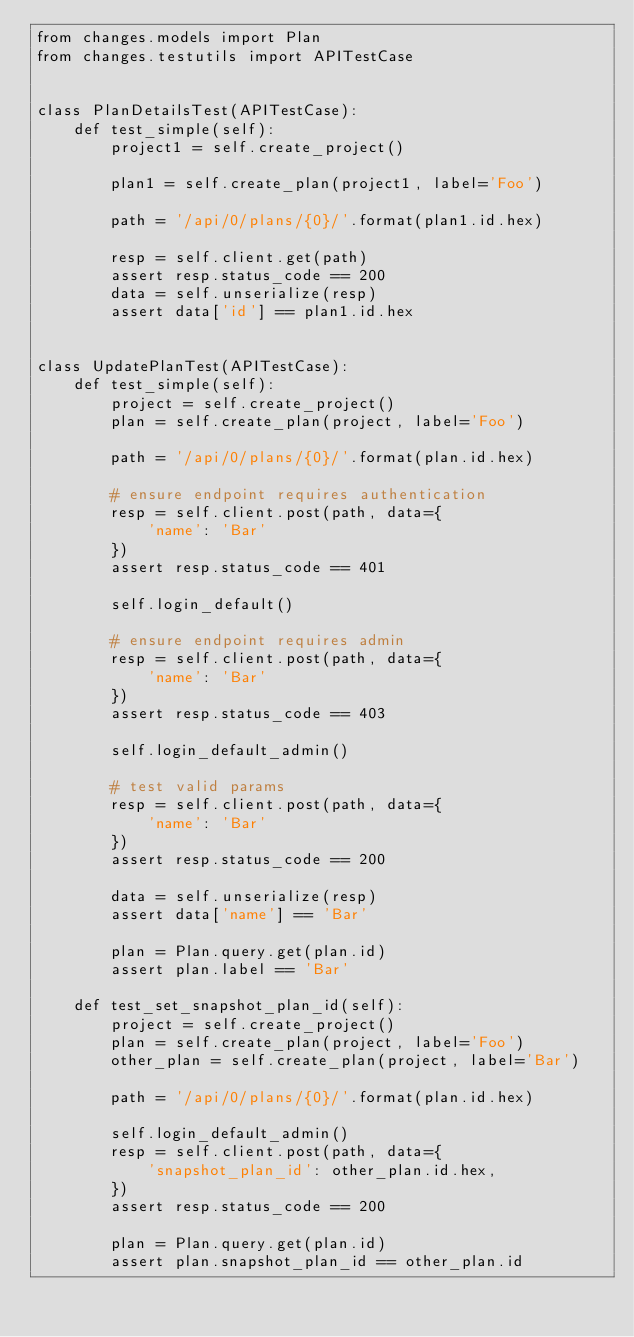<code> <loc_0><loc_0><loc_500><loc_500><_Python_>from changes.models import Plan
from changes.testutils import APITestCase


class PlanDetailsTest(APITestCase):
    def test_simple(self):
        project1 = self.create_project()

        plan1 = self.create_plan(project1, label='Foo')

        path = '/api/0/plans/{0}/'.format(plan1.id.hex)

        resp = self.client.get(path)
        assert resp.status_code == 200
        data = self.unserialize(resp)
        assert data['id'] == plan1.id.hex


class UpdatePlanTest(APITestCase):
    def test_simple(self):
        project = self.create_project()
        plan = self.create_plan(project, label='Foo')

        path = '/api/0/plans/{0}/'.format(plan.id.hex)

        # ensure endpoint requires authentication
        resp = self.client.post(path, data={
            'name': 'Bar'
        })
        assert resp.status_code == 401

        self.login_default()

        # ensure endpoint requires admin
        resp = self.client.post(path, data={
            'name': 'Bar'
        })
        assert resp.status_code == 403

        self.login_default_admin()

        # test valid params
        resp = self.client.post(path, data={
            'name': 'Bar'
        })
        assert resp.status_code == 200

        data = self.unserialize(resp)
        assert data['name'] == 'Bar'

        plan = Plan.query.get(plan.id)
        assert plan.label == 'Bar'

    def test_set_snapshot_plan_id(self):
        project = self.create_project()
        plan = self.create_plan(project, label='Foo')
        other_plan = self.create_plan(project, label='Bar')

        path = '/api/0/plans/{0}/'.format(plan.id.hex)

        self.login_default_admin()
        resp = self.client.post(path, data={
            'snapshot_plan_id': other_plan.id.hex,
        })
        assert resp.status_code == 200

        plan = Plan.query.get(plan.id)
        assert plan.snapshot_plan_id == other_plan.id
</code> 